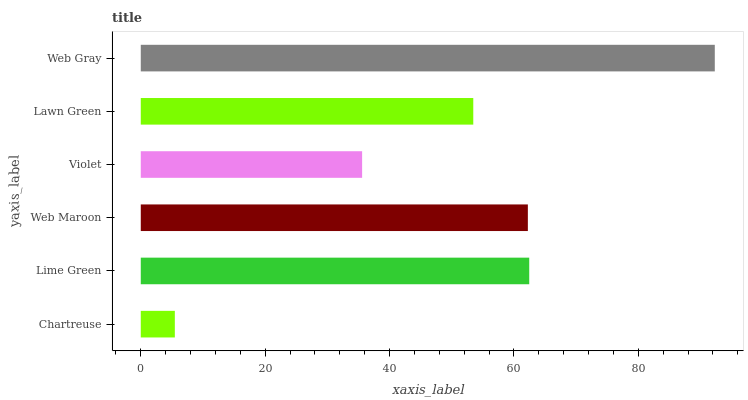Is Chartreuse the minimum?
Answer yes or no. Yes. Is Web Gray the maximum?
Answer yes or no. Yes. Is Lime Green the minimum?
Answer yes or no. No. Is Lime Green the maximum?
Answer yes or no. No. Is Lime Green greater than Chartreuse?
Answer yes or no. Yes. Is Chartreuse less than Lime Green?
Answer yes or no. Yes. Is Chartreuse greater than Lime Green?
Answer yes or no. No. Is Lime Green less than Chartreuse?
Answer yes or no. No. Is Web Maroon the high median?
Answer yes or no. Yes. Is Lawn Green the low median?
Answer yes or no. Yes. Is Violet the high median?
Answer yes or no. No. Is Chartreuse the low median?
Answer yes or no. No. 